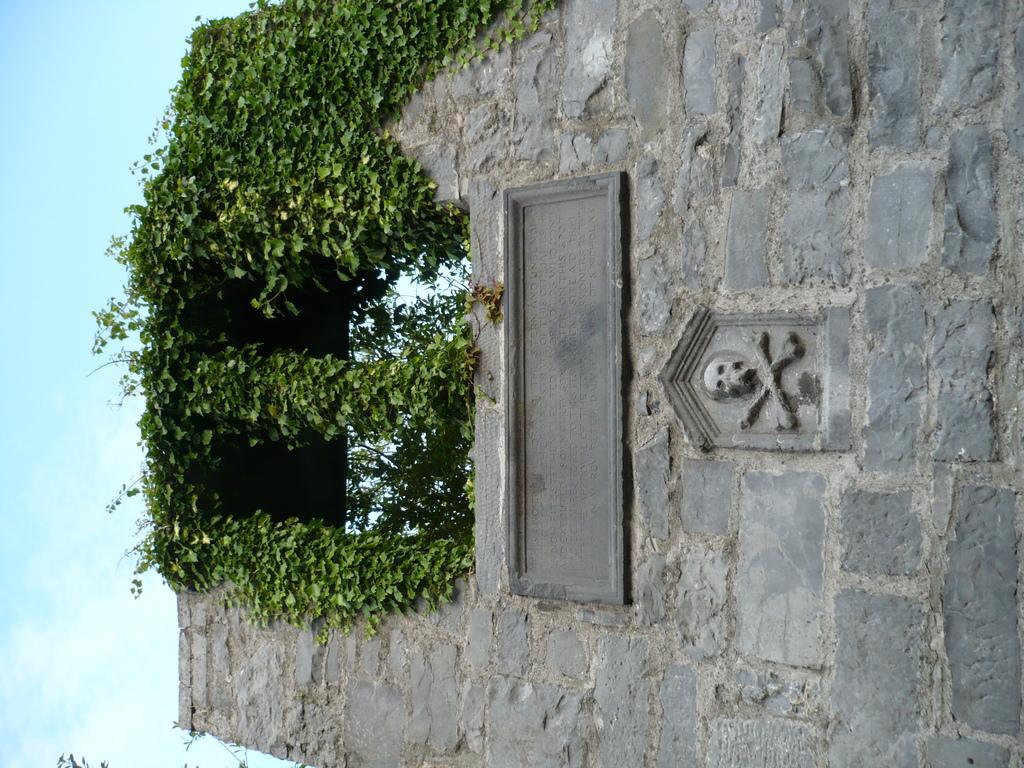How would you summarize this image in a sentence or two? In the foreground of this image, there is a stone wall and creepers on it. On the left, there is the sky. 